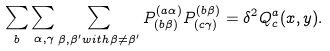Convert formula to latex. <formula><loc_0><loc_0><loc_500><loc_500>\sum _ { b } \sum _ { \alpha , \gamma } \sum _ { \beta , \beta ^ { \prime } w i t h \beta \neq \beta ^ { \prime } } P _ { ( b \beta ) } ^ { ( a \alpha ) } P _ { ( c \gamma ) } ^ { ( b \beta ) } = \delta ^ { 2 } Q _ { c } ^ { a } ( x , y ) .</formula> 